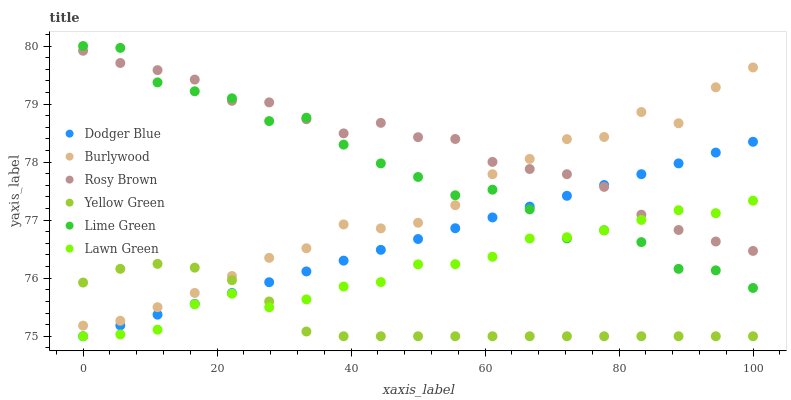Does Yellow Green have the minimum area under the curve?
Answer yes or no. Yes. Does Rosy Brown have the maximum area under the curve?
Answer yes or no. Yes. Does Burlywood have the minimum area under the curve?
Answer yes or no. No. Does Burlywood have the maximum area under the curve?
Answer yes or no. No. Is Dodger Blue the smoothest?
Answer yes or no. Yes. Is Lime Green the roughest?
Answer yes or no. Yes. Is Yellow Green the smoothest?
Answer yes or no. No. Is Yellow Green the roughest?
Answer yes or no. No. Does Lawn Green have the lowest value?
Answer yes or no. Yes. Does Burlywood have the lowest value?
Answer yes or no. No. Does Lime Green have the highest value?
Answer yes or no. Yes. Does Burlywood have the highest value?
Answer yes or no. No. Is Yellow Green less than Rosy Brown?
Answer yes or no. Yes. Is Lime Green greater than Yellow Green?
Answer yes or no. Yes. Does Lime Green intersect Rosy Brown?
Answer yes or no. Yes. Is Lime Green less than Rosy Brown?
Answer yes or no. No. Is Lime Green greater than Rosy Brown?
Answer yes or no. No. Does Yellow Green intersect Rosy Brown?
Answer yes or no. No. 